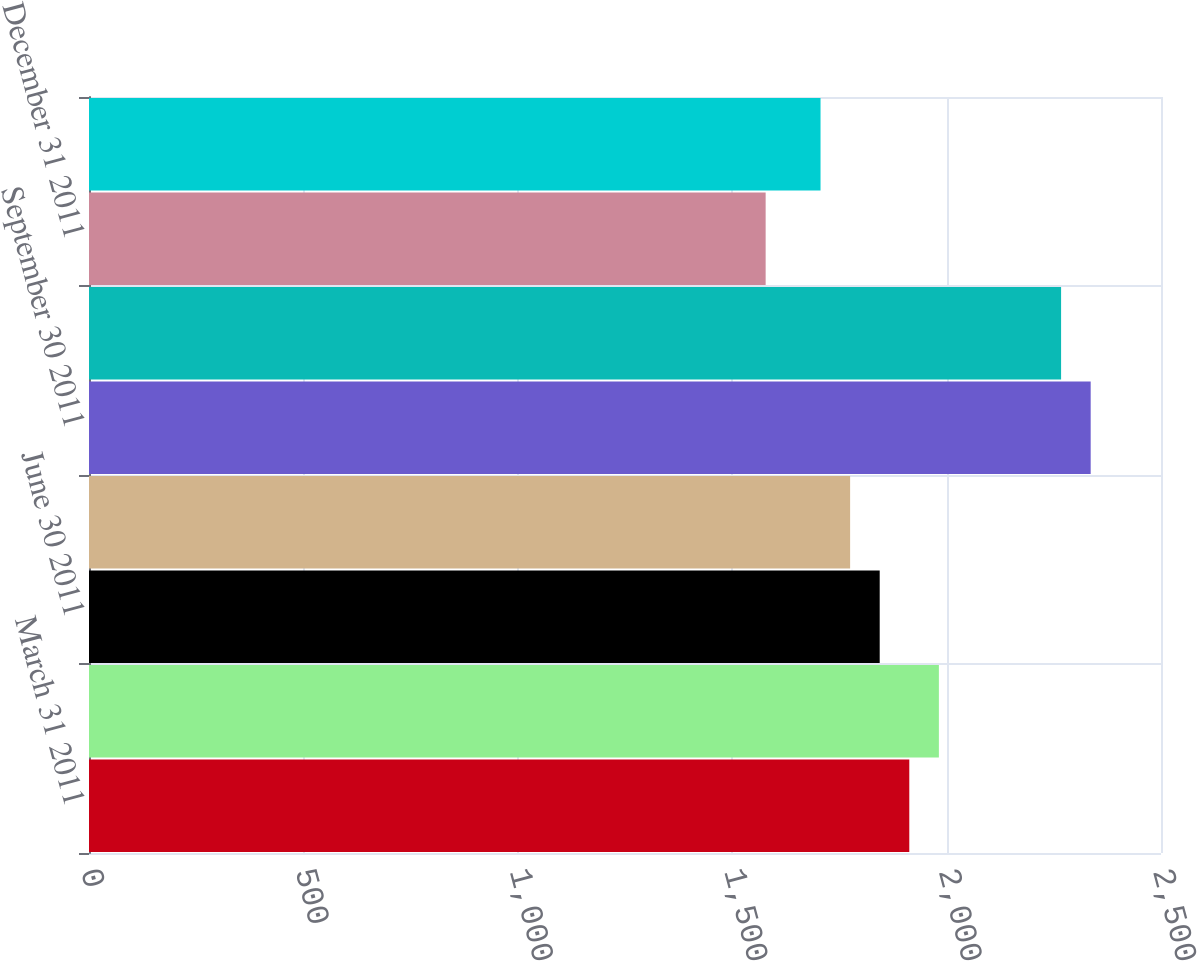Convert chart to OTSL. <chart><loc_0><loc_0><loc_500><loc_500><bar_chart><fcel>March 31 2011<fcel>March 31 2010<fcel>June 30 2011<fcel>June 30 2010<fcel>September 30 2011<fcel>September 30 2010<fcel>December 31 2011<fcel>December 31 2010<nl><fcel>1913<fcel>1982<fcel>1844<fcel>1775<fcel>2336<fcel>2267<fcel>1578<fcel>1706<nl></chart> 